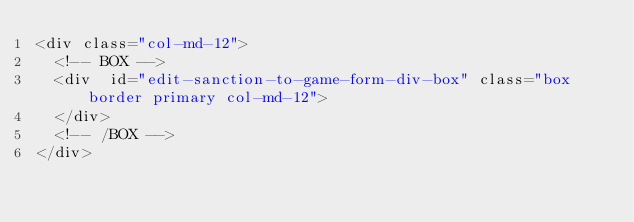Convert code to text. <code><loc_0><loc_0><loc_500><loc_500><_PHP_><div class="col-md-12">
	<!-- BOX -->
	<div  id="edit-sanction-to-game-form-div-box" class="box border primary col-md-12">
	</div>
	<!-- /BOX -->					
</div>
</code> 